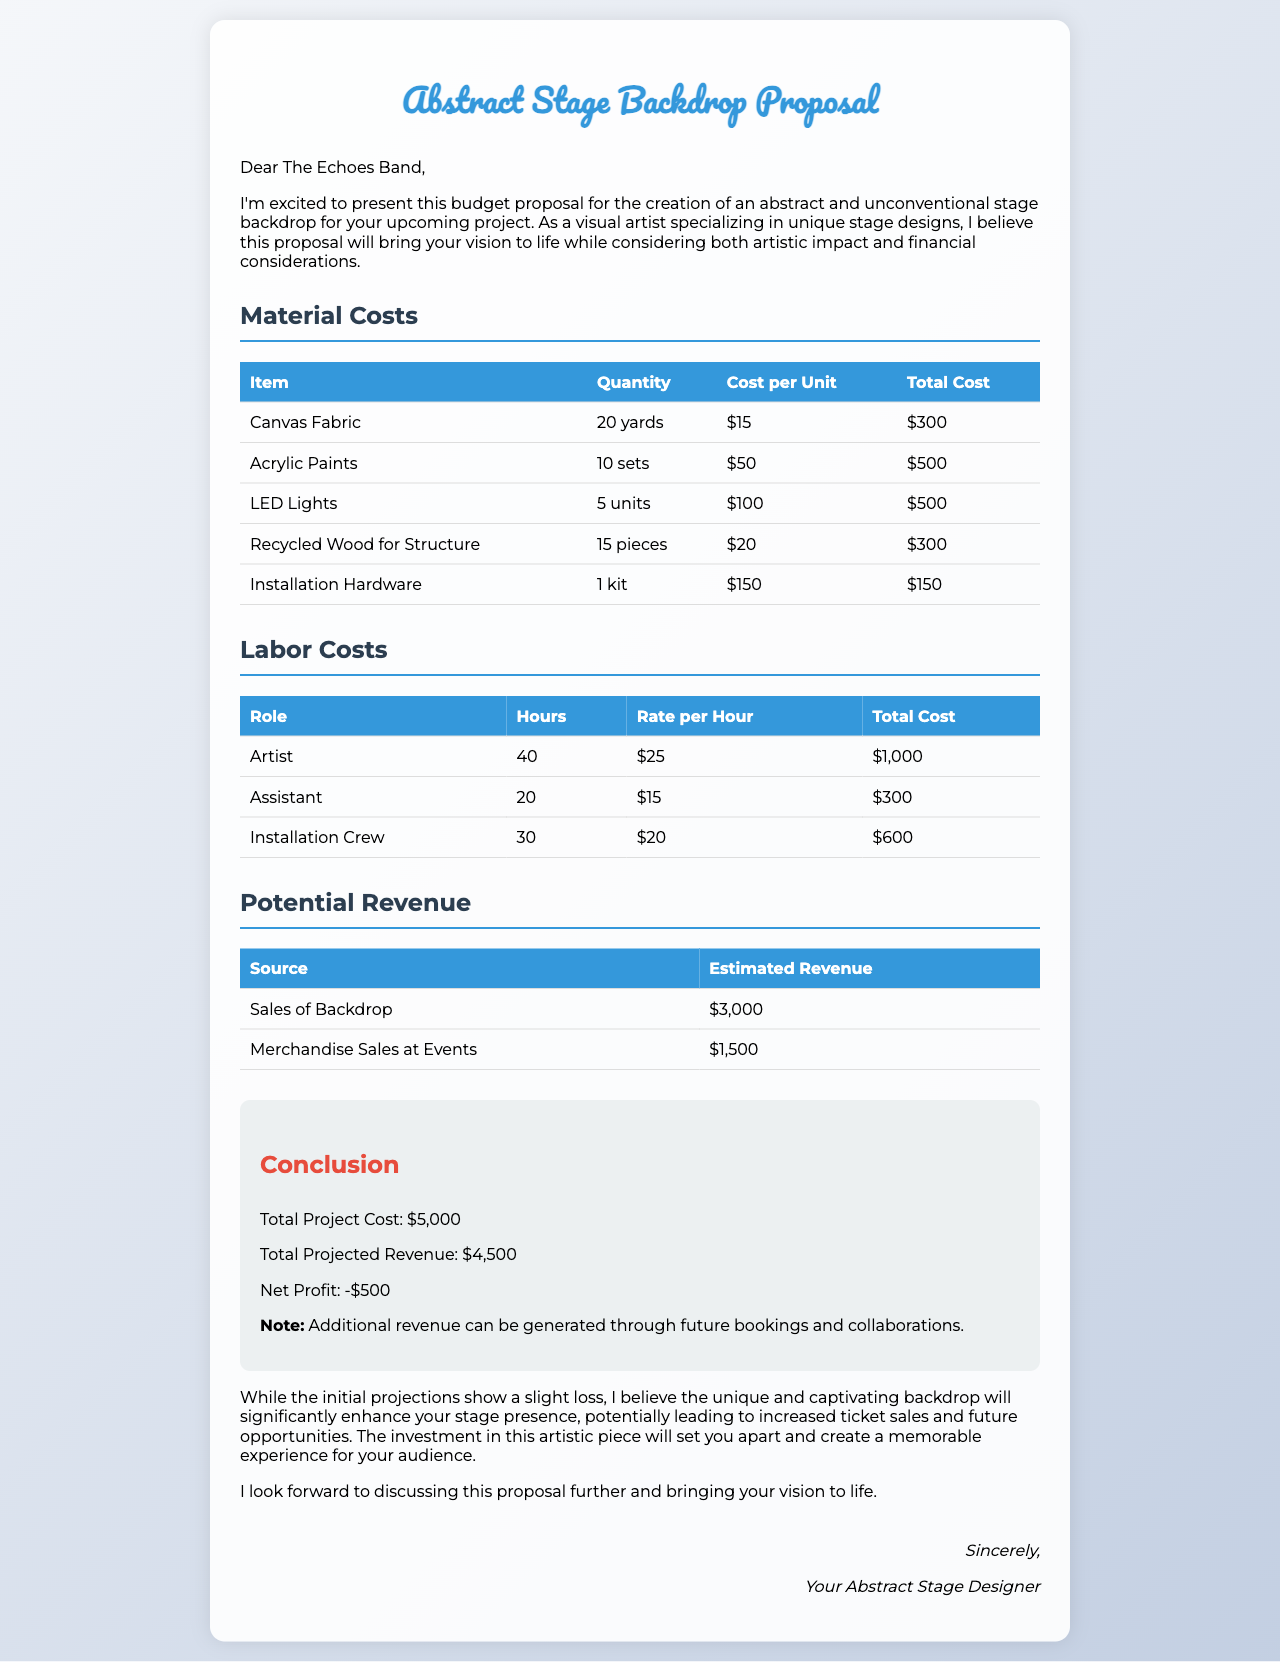what is the total cost of canvas fabric? The total cost of canvas fabric is detailed in the material costs section, which lists it as $300.
Answer: $300 how many sets of acrylic paints are included? The document specifies that there are 10 sets of acrylic paints listed in the material costs.
Answer: 10 sets what is the total project cost? The total project cost is summarized in the conclusion section as $5,000.
Answer: $5,000 who is responsible for installation? The document lists the "Installation Crew" as responsible for installation under labor costs.
Answer: Installation Crew what is the estimated revenue from merchandise sales at events? The document states the estimated revenue from merchandise sales at events is $1,500.
Answer: $1,500 how many pieces of recycled wood are required? The material costs detail that 15 pieces of recycled wood are needed for the project.
Answer: 15 pieces what is the net profit according to the proposal? The proposal calculates the net profit in the conclusion, indicating it as -$500.
Answer: -$500 who is the proposal addressed to? The proposal is addressed to "The Echoes Band," as mentioned at the beginning.
Answer: The Echoes Band how many hours is the artist expected to work on the project? The labor costs section specifies that the artist is expected to work 40 hours on the project.
Answer: 40 hours 